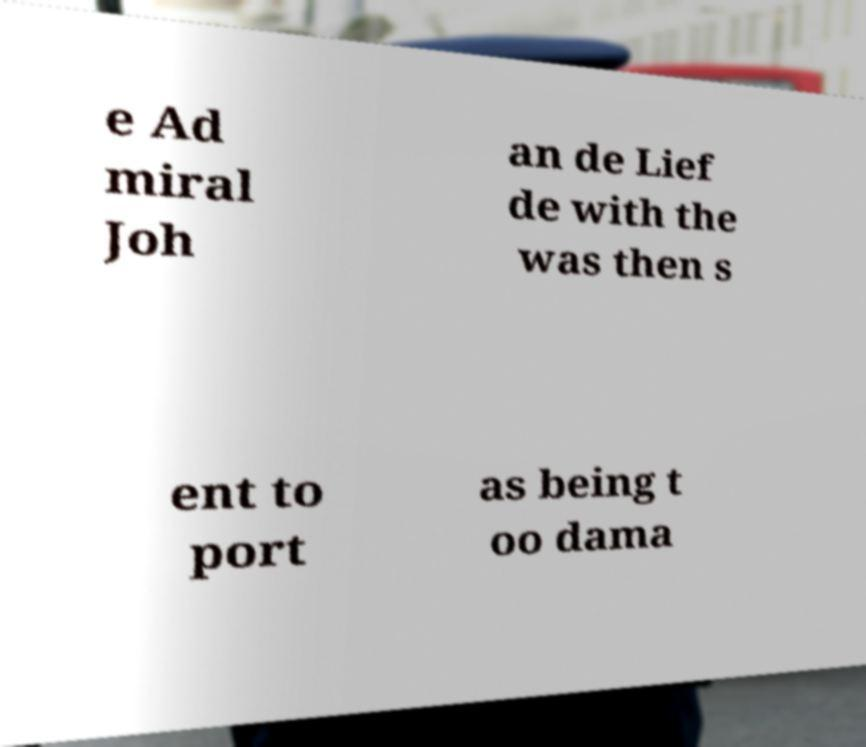For documentation purposes, I need the text within this image transcribed. Could you provide that? e Ad miral Joh an de Lief de with the was then s ent to port as being t oo dama 